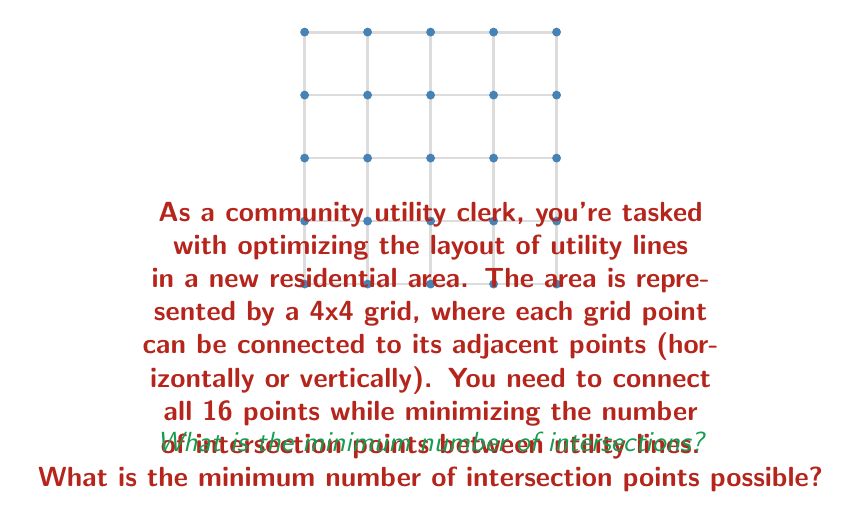Solve this math problem. Let's approach this step-by-step:

1) First, we need to understand that the minimum number of lines needed to connect all points is 15. This is because we have 16 points, and each line connects 2 points.

2) The key to minimizing intersections is to create as many parallel lines as possible. Parallel lines never intersect.

3) In a 4x4 grid, we can create two sets of parallel lines:
   - 4 horizontal lines
   - 4 vertical lines

4) These 8 lines (4 horizontal + 4 vertical) will connect all 16 points without any intersections.

5) However, we need 7 more lines to reach the required 15 lines. Each of these additional lines will inevitably create intersections.

6) The optimal way to add these 7 lines is to make them diagonal, connecting corners or edges. Each diagonal line will intersect with 4 of the existing perpendicular lines.

7) Therefore, the total number of intersections will be:
   $$ 7 \text{ (diagonal lines)} \times 4 \text{ (intersections per line)} = 28 $$

8) This is the minimum number of intersections possible while connecting all points with 15 lines.
Answer: 28 intersection points 